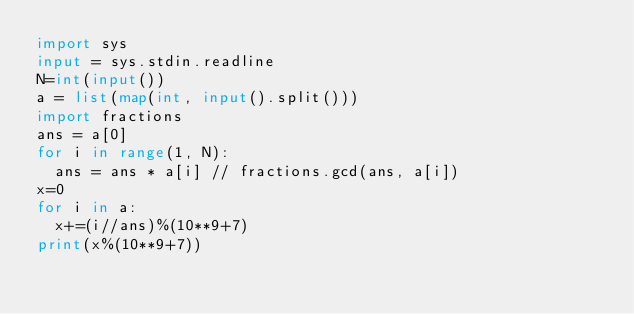<code> <loc_0><loc_0><loc_500><loc_500><_Python_>import sys
input = sys.stdin.readline
N=int(input())
a = list(map(int, input().split()))
import fractions
ans = a[0]
for i in range(1, N):
  ans = ans * a[i] // fractions.gcd(ans, a[i])
x=0
for i in a:
  x+=(i//ans)%(10**9+7)
print(x%(10**9+7))</code> 